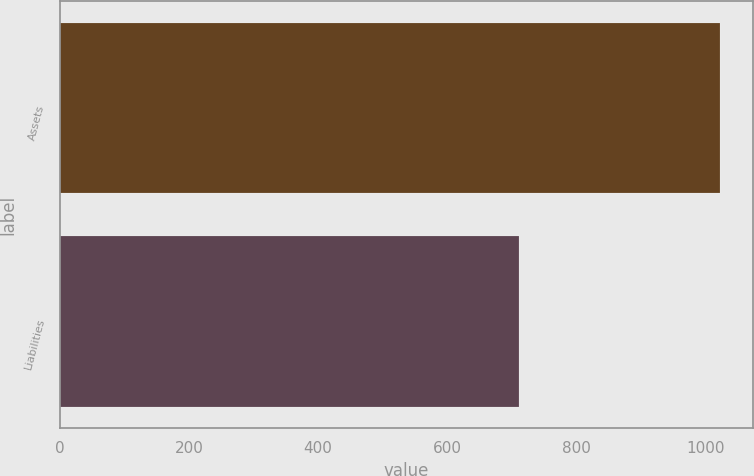Convert chart. <chart><loc_0><loc_0><loc_500><loc_500><bar_chart><fcel>Assets<fcel>Liabilities<nl><fcel>1023<fcel>712<nl></chart> 